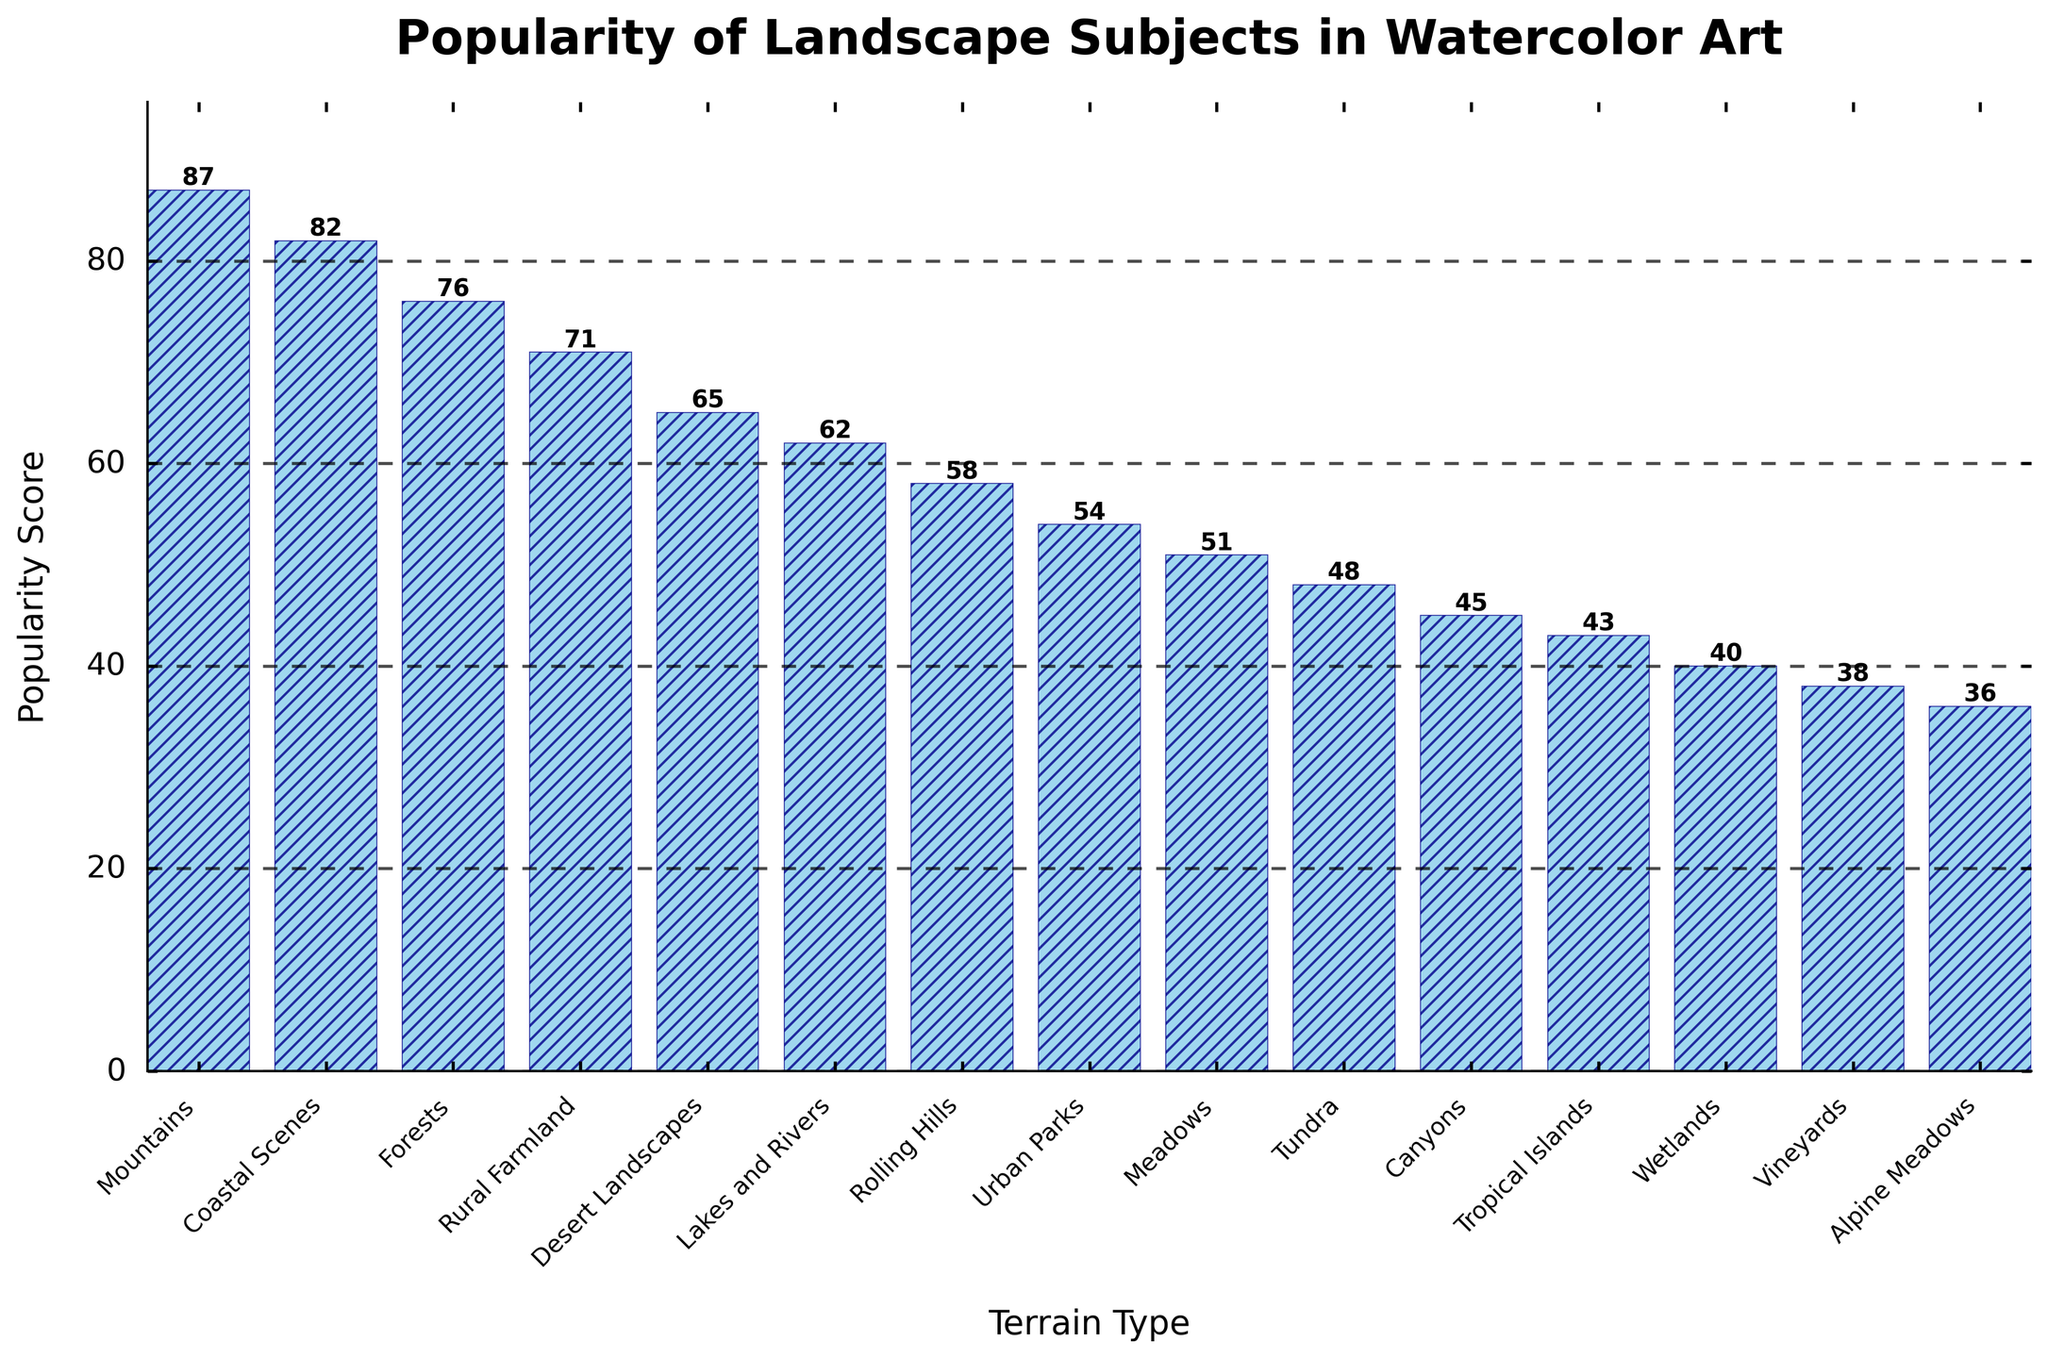Which terrain type has the highest popularity score? Look for the bar that reaches the highest on the y-axis. The 'Mountains' bar is the tallest, representing an 87 on the popularity scale.
Answer: Mountains Which terrain type has the lowest popularity score? Identify the shortest bar on the plot. 'Alpine Meadows' is the bar with the lowest height, showing a popularity score of 36.
Answer: Alpine Meadows Compare the popularity scores between 'Mountains' and 'Desert Landscapes'. Which one is more popular and by how much? The bar for 'Mountains' is higher than the bar for 'Desert Landscapes'. 'Mountains' has a score of 87, while 'Desert Landscapes' has a score of 65. The difference is 87 - 65.
Answer: Mountains by 22 What is the average popularity score of the top 3 terrain types? Sum the scores of the top 3 bars: Mountains (87), Coastal Scenes (82), and Forests (76). The total is 87 + 82 + 76 = 245. The average is 245 / 3.
Answer: 81.67 Which terrain types have a popularity score above 70? Look for bars that extend above the 70 mark on the y-axis. The terrain types above 70 are 'Mountains', 'Coastal Scenes', 'Forests', and 'Rural Farmland'.
Answer: Mountains, Coastal Scenes, Forests, and Rural Farmland How much more popular are Lakes and Rivers compared to Wetlands? Find the heights of the bars for 'Lakes and Rivers' (62) and 'Wetlands' (40). The difference is calculated as 62 - 40.
Answer: 22 Calculate the total popularity score of the terrain types categorized under 50. Identify the terrain types with scores under 50: Wetlands (40), Vineyards (38), Alpine Meadows (36), Tundra (48), Canyons (45), and Tropical Islands (43). Sum their scores: 40 + 38 + 36 + 48 + 45 + 43. The total is 250.
Answer: 250 How many terrain types have a popularity score between 50 and 70? Find the bars representing popularity scores greater than or equal to 50 and less than or equal to 70: Lakes and Rivers (62), Rural Farmland (71), Rolling Hills (58), Meadows (51), and Desert Landscapes (65). Count these types.
Answer: 5 Is Urban Parks more popular than Meadows? Compare the heights of the bars for 'Urban Parks' (54) and 'Meadows' (51). 'Urban Parks' has a higher score.
Answer: Yes 